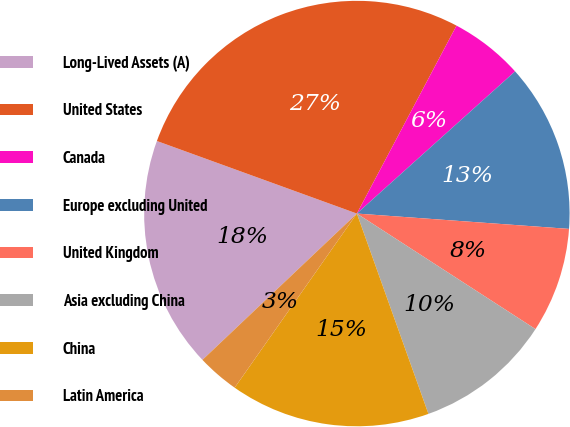Convert chart to OTSL. <chart><loc_0><loc_0><loc_500><loc_500><pie_chart><fcel>Long-Lived Assets (A)<fcel>United States<fcel>Canada<fcel>Europe excluding United<fcel>United Kingdom<fcel>Asia excluding China<fcel>China<fcel>Latin America<nl><fcel>17.61%<fcel>27.22%<fcel>5.59%<fcel>12.8%<fcel>7.99%<fcel>10.4%<fcel>15.2%<fcel>3.19%<nl></chart> 